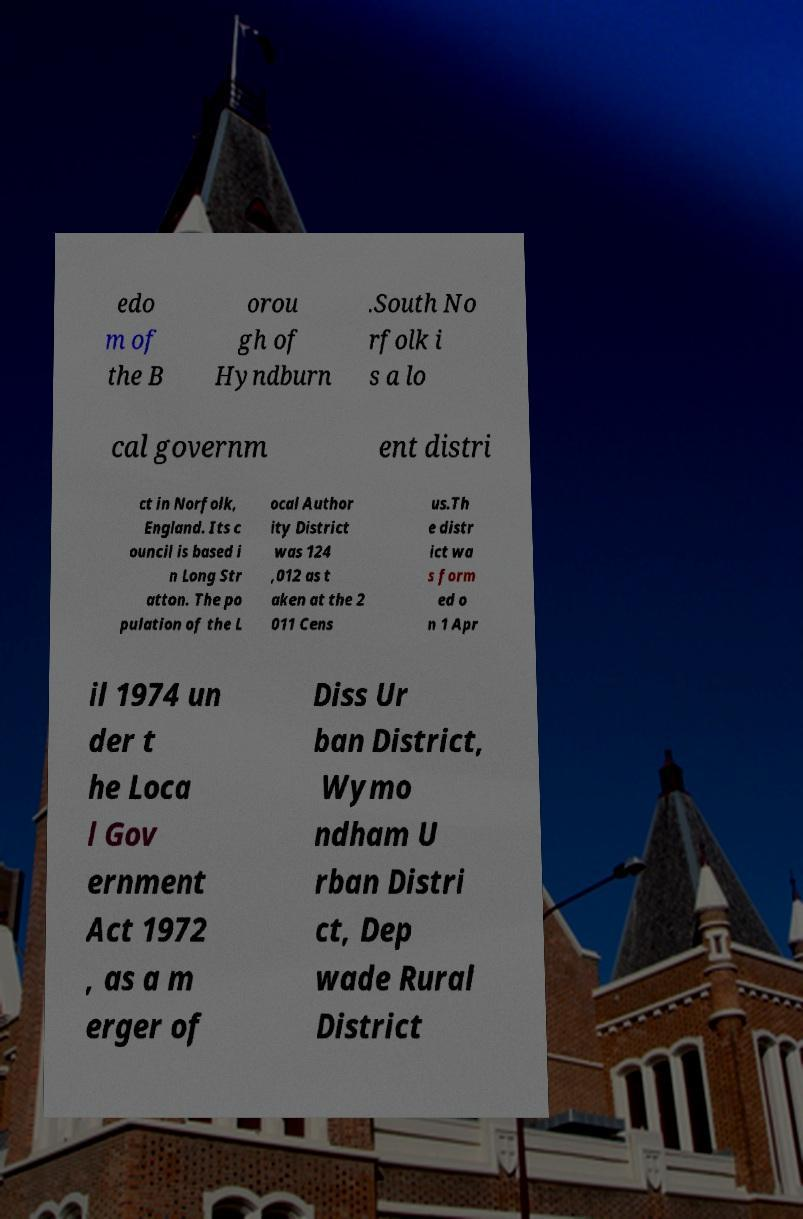Please read and relay the text visible in this image. What does it say? edo m of the B orou gh of Hyndburn .South No rfolk i s a lo cal governm ent distri ct in Norfolk, England. Its c ouncil is based i n Long Str atton. The po pulation of the L ocal Author ity District was 124 ,012 as t aken at the 2 011 Cens us.Th e distr ict wa s form ed o n 1 Apr il 1974 un der t he Loca l Gov ernment Act 1972 , as a m erger of Diss Ur ban District, Wymo ndham U rban Distri ct, Dep wade Rural District 